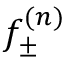<formula> <loc_0><loc_0><loc_500><loc_500>f _ { \pm } ^ { ( n ) }</formula> 